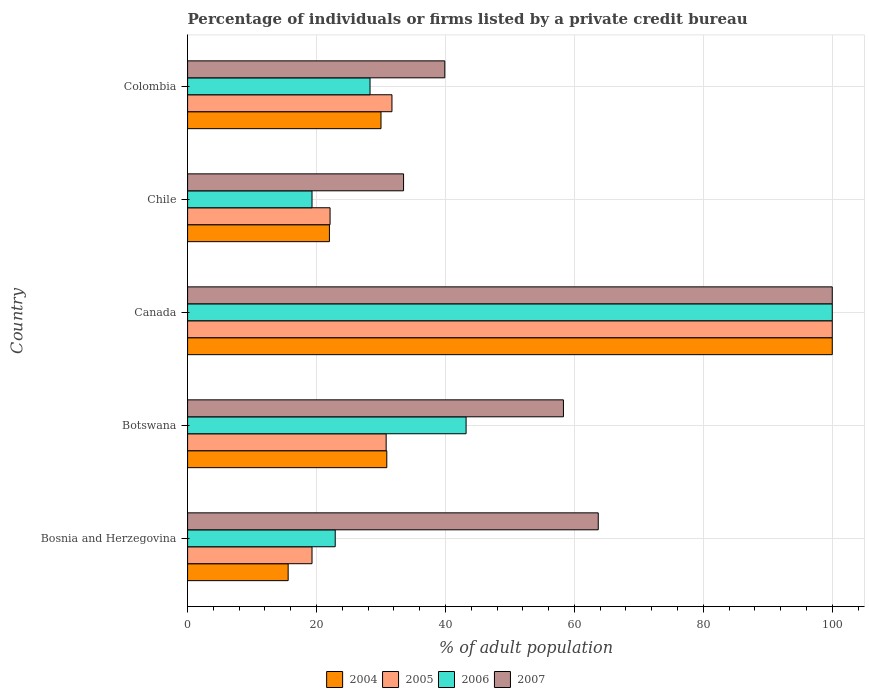Are the number of bars per tick equal to the number of legend labels?
Provide a succinct answer. Yes. Are the number of bars on each tick of the Y-axis equal?
Offer a terse response. Yes. How many bars are there on the 1st tick from the top?
Make the answer very short. 4. How many bars are there on the 1st tick from the bottom?
Provide a succinct answer. 4. What is the label of the 3rd group of bars from the top?
Offer a very short reply. Canada. What is the percentage of population listed by a private credit bureau in 2005 in Bosnia and Herzegovina?
Ensure brevity in your answer.  19.3. Across all countries, what is the maximum percentage of population listed by a private credit bureau in 2005?
Offer a terse response. 100. Across all countries, what is the minimum percentage of population listed by a private credit bureau in 2007?
Your answer should be very brief. 33.5. What is the total percentage of population listed by a private credit bureau in 2006 in the graph?
Your answer should be very brief. 213.7. What is the difference between the percentage of population listed by a private credit bureau in 2004 in Botswana and that in Colombia?
Offer a very short reply. 0.9. What is the difference between the percentage of population listed by a private credit bureau in 2007 in Bosnia and Herzegovina and the percentage of population listed by a private credit bureau in 2006 in Canada?
Provide a short and direct response. -36.3. What is the average percentage of population listed by a private credit bureau in 2007 per country?
Your answer should be compact. 59.08. What is the difference between the percentage of population listed by a private credit bureau in 2006 and percentage of population listed by a private credit bureau in 2005 in Bosnia and Herzegovina?
Ensure brevity in your answer.  3.6. What is the ratio of the percentage of population listed by a private credit bureau in 2004 in Botswana to that in Canada?
Make the answer very short. 0.31. Is the percentage of population listed by a private credit bureau in 2006 in Botswana less than that in Colombia?
Your answer should be very brief. No. Is the difference between the percentage of population listed by a private credit bureau in 2006 in Canada and Colombia greater than the difference between the percentage of population listed by a private credit bureau in 2005 in Canada and Colombia?
Offer a very short reply. Yes. What is the difference between the highest and the second highest percentage of population listed by a private credit bureau in 2005?
Your response must be concise. 68.3. What is the difference between the highest and the lowest percentage of population listed by a private credit bureau in 2007?
Ensure brevity in your answer.  66.5. Is it the case that in every country, the sum of the percentage of population listed by a private credit bureau in 2005 and percentage of population listed by a private credit bureau in 2006 is greater than the sum of percentage of population listed by a private credit bureau in 2004 and percentage of population listed by a private credit bureau in 2007?
Ensure brevity in your answer.  No. What does the 3rd bar from the top in Bosnia and Herzegovina represents?
Keep it short and to the point. 2005. What does the 1st bar from the bottom in Colombia represents?
Offer a terse response. 2004. Is it the case that in every country, the sum of the percentage of population listed by a private credit bureau in 2007 and percentage of population listed by a private credit bureau in 2006 is greater than the percentage of population listed by a private credit bureau in 2004?
Your answer should be compact. Yes. How many bars are there?
Your answer should be very brief. 20. Does the graph contain any zero values?
Keep it short and to the point. No. Does the graph contain grids?
Provide a short and direct response. Yes. What is the title of the graph?
Give a very brief answer. Percentage of individuals or firms listed by a private credit bureau. What is the label or title of the X-axis?
Offer a very short reply. % of adult population. What is the % of adult population of 2005 in Bosnia and Herzegovina?
Provide a short and direct response. 19.3. What is the % of adult population in 2006 in Bosnia and Herzegovina?
Offer a terse response. 22.9. What is the % of adult population of 2007 in Bosnia and Herzegovina?
Make the answer very short. 63.7. What is the % of adult population in 2004 in Botswana?
Provide a short and direct response. 30.9. What is the % of adult population in 2005 in Botswana?
Give a very brief answer. 30.8. What is the % of adult population in 2006 in Botswana?
Provide a short and direct response. 43.2. What is the % of adult population of 2007 in Botswana?
Offer a terse response. 58.3. What is the % of adult population in 2004 in Canada?
Your answer should be very brief. 100. What is the % of adult population of 2007 in Canada?
Ensure brevity in your answer.  100. What is the % of adult population in 2004 in Chile?
Your answer should be compact. 22. What is the % of adult population in 2005 in Chile?
Provide a succinct answer. 22.1. What is the % of adult population in 2006 in Chile?
Your answer should be very brief. 19.3. What is the % of adult population of 2007 in Chile?
Keep it short and to the point. 33.5. What is the % of adult population in 2004 in Colombia?
Provide a short and direct response. 30. What is the % of adult population in 2005 in Colombia?
Offer a terse response. 31.7. What is the % of adult population of 2006 in Colombia?
Offer a very short reply. 28.3. What is the % of adult population in 2007 in Colombia?
Provide a succinct answer. 39.9. Across all countries, what is the maximum % of adult population in 2004?
Make the answer very short. 100. Across all countries, what is the maximum % of adult population of 2005?
Give a very brief answer. 100. Across all countries, what is the maximum % of adult population in 2007?
Ensure brevity in your answer.  100. Across all countries, what is the minimum % of adult population in 2005?
Give a very brief answer. 19.3. Across all countries, what is the minimum % of adult population of 2006?
Offer a very short reply. 19.3. Across all countries, what is the minimum % of adult population in 2007?
Give a very brief answer. 33.5. What is the total % of adult population of 2004 in the graph?
Your answer should be compact. 198.5. What is the total % of adult population in 2005 in the graph?
Your answer should be very brief. 203.9. What is the total % of adult population in 2006 in the graph?
Give a very brief answer. 213.7. What is the total % of adult population of 2007 in the graph?
Provide a succinct answer. 295.4. What is the difference between the % of adult population in 2004 in Bosnia and Herzegovina and that in Botswana?
Provide a succinct answer. -15.3. What is the difference between the % of adult population in 2005 in Bosnia and Herzegovina and that in Botswana?
Provide a succinct answer. -11.5. What is the difference between the % of adult population in 2006 in Bosnia and Herzegovina and that in Botswana?
Give a very brief answer. -20.3. What is the difference between the % of adult population in 2007 in Bosnia and Herzegovina and that in Botswana?
Make the answer very short. 5.4. What is the difference between the % of adult population of 2004 in Bosnia and Herzegovina and that in Canada?
Give a very brief answer. -84.4. What is the difference between the % of adult population in 2005 in Bosnia and Herzegovina and that in Canada?
Ensure brevity in your answer.  -80.7. What is the difference between the % of adult population of 2006 in Bosnia and Herzegovina and that in Canada?
Keep it short and to the point. -77.1. What is the difference between the % of adult population of 2007 in Bosnia and Herzegovina and that in Canada?
Your response must be concise. -36.3. What is the difference between the % of adult population in 2004 in Bosnia and Herzegovina and that in Chile?
Offer a very short reply. -6.4. What is the difference between the % of adult population of 2005 in Bosnia and Herzegovina and that in Chile?
Provide a short and direct response. -2.8. What is the difference between the % of adult population in 2006 in Bosnia and Herzegovina and that in Chile?
Offer a terse response. 3.6. What is the difference between the % of adult population of 2007 in Bosnia and Herzegovina and that in Chile?
Offer a very short reply. 30.2. What is the difference between the % of adult population of 2004 in Bosnia and Herzegovina and that in Colombia?
Keep it short and to the point. -14.4. What is the difference between the % of adult population in 2006 in Bosnia and Herzegovina and that in Colombia?
Provide a succinct answer. -5.4. What is the difference between the % of adult population of 2007 in Bosnia and Herzegovina and that in Colombia?
Offer a very short reply. 23.8. What is the difference between the % of adult population of 2004 in Botswana and that in Canada?
Give a very brief answer. -69.1. What is the difference between the % of adult population of 2005 in Botswana and that in Canada?
Make the answer very short. -69.2. What is the difference between the % of adult population of 2006 in Botswana and that in Canada?
Your answer should be very brief. -56.8. What is the difference between the % of adult population in 2007 in Botswana and that in Canada?
Provide a short and direct response. -41.7. What is the difference between the % of adult population of 2004 in Botswana and that in Chile?
Keep it short and to the point. 8.9. What is the difference between the % of adult population of 2006 in Botswana and that in Chile?
Provide a succinct answer. 23.9. What is the difference between the % of adult population in 2007 in Botswana and that in Chile?
Your answer should be compact. 24.8. What is the difference between the % of adult population of 2004 in Botswana and that in Colombia?
Keep it short and to the point. 0.9. What is the difference between the % of adult population in 2005 in Botswana and that in Colombia?
Your answer should be compact. -0.9. What is the difference between the % of adult population in 2006 in Botswana and that in Colombia?
Provide a short and direct response. 14.9. What is the difference between the % of adult population of 2004 in Canada and that in Chile?
Keep it short and to the point. 78. What is the difference between the % of adult population in 2005 in Canada and that in Chile?
Keep it short and to the point. 77.9. What is the difference between the % of adult population in 2006 in Canada and that in Chile?
Keep it short and to the point. 80.7. What is the difference between the % of adult population in 2007 in Canada and that in Chile?
Your answer should be very brief. 66.5. What is the difference between the % of adult population in 2004 in Canada and that in Colombia?
Your answer should be compact. 70. What is the difference between the % of adult population of 2005 in Canada and that in Colombia?
Make the answer very short. 68.3. What is the difference between the % of adult population in 2006 in Canada and that in Colombia?
Ensure brevity in your answer.  71.7. What is the difference between the % of adult population in 2007 in Canada and that in Colombia?
Provide a short and direct response. 60.1. What is the difference between the % of adult population of 2006 in Chile and that in Colombia?
Offer a very short reply. -9. What is the difference between the % of adult population of 2004 in Bosnia and Herzegovina and the % of adult population of 2005 in Botswana?
Make the answer very short. -15.2. What is the difference between the % of adult population of 2004 in Bosnia and Herzegovina and the % of adult population of 2006 in Botswana?
Your answer should be compact. -27.6. What is the difference between the % of adult population of 2004 in Bosnia and Herzegovina and the % of adult population of 2007 in Botswana?
Offer a very short reply. -42.7. What is the difference between the % of adult population of 2005 in Bosnia and Herzegovina and the % of adult population of 2006 in Botswana?
Keep it short and to the point. -23.9. What is the difference between the % of adult population of 2005 in Bosnia and Herzegovina and the % of adult population of 2007 in Botswana?
Ensure brevity in your answer.  -39. What is the difference between the % of adult population in 2006 in Bosnia and Herzegovina and the % of adult population in 2007 in Botswana?
Your answer should be very brief. -35.4. What is the difference between the % of adult population of 2004 in Bosnia and Herzegovina and the % of adult population of 2005 in Canada?
Your answer should be very brief. -84.4. What is the difference between the % of adult population in 2004 in Bosnia and Herzegovina and the % of adult population in 2006 in Canada?
Offer a very short reply. -84.4. What is the difference between the % of adult population in 2004 in Bosnia and Herzegovina and the % of adult population in 2007 in Canada?
Make the answer very short. -84.4. What is the difference between the % of adult population in 2005 in Bosnia and Herzegovina and the % of adult population in 2006 in Canada?
Provide a succinct answer. -80.7. What is the difference between the % of adult population of 2005 in Bosnia and Herzegovina and the % of adult population of 2007 in Canada?
Ensure brevity in your answer.  -80.7. What is the difference between the % of adult population in 2006 in Bosnia and Herzegovina and the % of adult population in 2007 in Canada?
Offer a terse response. -77.1. What is the difference between the % of adult population in 2004 in Bosnia and Herzegovina and the % of adult population in 2005 in Chile?
Your response must be concise. -6.5. What is the difference between the % of adult population of 2004 in Bosnia and Herzegovina and the % of adult population of 2007 in Chile?
Your answer should be compact. -17.9. What is the difference between the % of adult population in 2005 in Bosnia and Herzegovina and the % of adult population in 2006 in Chile?
Offer a terse response. 0. What is the difference between the % of adult population of 2005 in Bosnia and Herzegovina and the % of adult population of 2007 in Chile?
Keep it short and to the point. -14.2. What is the difference between the % of adult population of 2004 in Bosnia and Herzegovina and the % of adult population of 2005 in Colombia?
Your response must be concise. -16.1. What is the difference between the % of adult population of 2004 in Bosnia and Herzegovina and the % of adult population of 2006 in Colombia?
Offer a terse response. -12.7. What is the difference between the % of adult population in 2004 in Bosnia and Herzegovina and the % of adult population in 2007 in Colombia?
Your answer should be compact. -24.3. What is the difference between the % of adult population in 2005 in Bosnia and Herzegovina and the % of adult population in 2006 in Colombia?
Your answer should be very brief. -9. What is the difference between the % of adult population of 2005 in Bosnia and Herzegovina and the % of adult population of 2007 in Colombia?
Your response must be concise. -20.6. What is the difference between the % of adult population of 2006 in Bosnia and Herzegovina and the % of adult population of 2007 in Colombia?
Your response must be concise. -17. What is the difference between the % of adult population of 2004 in Botswana and the % of adult population of 2005 in Canada?
Your response must be concise. -69.1. What is the difference between the % of adult population in 2004 in Botswana and the % of adult population in 2006 in Canada?
Ensure brevity in your answer.  -69.1. What is the difference between the % of adult population of 2004 in Botswana and the % of adult population of 2007 in Canada?
Your answer should be very brief. -69.1. What is the difference between the % of adult population of 2005 in Botswana and the % of adult population of 2006 in Canada?
Make the answer very short. -69.2. What is the difference between the % of adult population in 2005 in Botswana and the % of adult population in 2007 in Canada?
Offer a very short reply. -69.2. What is the difference between the % of adult population of 2006 in Botswana and the % of adult population of 2007 in Canada?
Give a very brief answer. -56.8. What is the difference between the % of adult population in 2004 in Botswana and the % of adult population in 2007 in Chile?
Your response must be concise. -2.6. What is the difference between the % of adult population in 2006 in Botswana and the % of adult population in 2007 in Chile?
Your answer should be compact. 9.7. What is the difference between the % of adult population in 2004 in Botswana and the % of adult population in 2005 in Colombia?
Ensure brevity in your answer.  -0.8. What is the difference between the % of adult population in 2005 in Botswana and the % of adult population in 2006 in Colombia?
Your answer should be very brief. 2.5. What is the difference between the % of adult population of 2005 in Botswana and the % of adult population of 2007 in Colombia?
Offer a very short reply. -9.1. What is the difference between the % of adult population in 2006 in Botswana and the % of adult population in 2007 in Colombia?
Make the answer very short. 3.3. What is the difference between the % of adult population of 2004 in Canada and the % of adult population of 2005 in Chile?
Offer a terse response. 77.9. What is the difference between the % of adult population of 2004 in Canada and the % of adult population of 2006 in Chile?
Provide a succinct answer. 80.7. What is the difference between the % of adult population of 2004 in Canada and the % of adult population of 2007 in Chile?
Offer a terse response. 66.5. What is the difference between the % of adult population in 2005 in Canada and the % of adult population in 2006 in Chile?
Offer a very short reply. 80.7. What is the difference between the % of adult population of 2005 in Canada and the % of adult population of 2007 in Chile?
Offer a terse response. 66.5. What is the difference between the % of adult population in 2006 in Canada and the % of adult population in 2007 in Chile?
Your response must be concise. 66.5. What is the difference between the % of adult population of 2004 in Canada and the % of adult population of 2005 in Colombia?
Your answer should be compact. 68.3. What is the difference between the % of adult population in 2004 in Canada and the % of adult population in 2006 in Colombia?
Provide a short and direct response. 71.7. What is the difference between the % of adult population in 2004 in Canada and the % of adult population in 2007 in Colombia?
Give a very brief answer. 60.1. What is the difference between the % of adult population of 2005 in Canada and the % of adult population of 2006 in Colombia?
Your answer should be compact. 71.7. What is the difference between the % of adult population of 2005 in Canada and the % of adult population of 2007 in Colombia?
Offer a very short reply. 60.1. What is the difference between the % of adult population of 2006 in Canada and the % of adult population of 2007 in Colombia?
Make the answer very short. 60.1. What is the difference between the % of adult population in 2004 in Chile and the % of adult population in 2007 in Colombia?
Give a very brief answer. -17.9. What is the difference between the % of adult population in 2005 in Chile and the % of adult population in 2007 in Colombia?
Your answer should be compact. -17.8. What is the difference between the % of adult population of 2006 in Chile and the % of adult population of 2007 in Colombia?
Your response must be concise. -20.6. What is the average % of adult population of 2004 per country?
Give a very brief answer. 39.7. What is the average % of adult population in 2005 per country?
Provide a succinct answer. 40.78. What is the average % of adult population in 2006 per country?
Keep it short and to the point. 42.74. What is the average % of adult population in 2007 per country?
Provide a succinct answer. 59.08. What is the difference between the % of adult population in 2004 and % of adult population in 2006 in Bosnia and Herzegovina?
Your response must be concise. -7.3. What is the difference between the % of adult population in 2004 and % of adult population in 2007 in Bosnia and Herzegovina?
Offer a very short reply. -48.1. What is the difference between the % of adult population in 2005 and % of adult population in 2006 in Bosnia and Herzegovina?
Make the answer very short. -3.6. What is the difference between the % of adult population in 2005 and % of adult population in 2007 in Bosnia and Herzegovina?
Your response must be concise. -44.4. What is the difference between the % of adult population of 2006 and % of adult population of 2007 in Bosnia and Herzegovina?
Offer a very short reply. -40.8. What is the difference between the % of adult population of 2004 and % of adult population of 2005 in Botswana?
Provide a short and direct response. 0.1. What is the difference between the % of adult population in 2004 and % of adult population in 2006 in Botswana?
Provide a succinct answer. -12.3. What is the difference between the % of adult population of 2004 and % of adult population of 2007 in Botswana?
Your answer should be very brief. -27.4. What is the difference between the % of adult population in 2005 and % of adult population in 2006 in Botswana?
Provide a succinct answer. -12.4. What is the difference between the % of adult population in 2005 and % of adult population in 2007 in Botswana?
Provide a short and direct response. -27.5. What is the difference between the % of adult population of 2006 and % of adult population of 2007 in Botswana?
Offer a very short reply. -15.1. What is the difference between the % of adult population in 2004 and % of adult population in 2005 in Canada?
Your answer should be very brief. 0. What is the difference between the % of adult population in 2004 and % of adult population in 2007 in Canada?
Your response must be concise. 0. What is the difference between the % of adult population of 2005 and % of adult population of 2006 in Canada?
Your answer should be very brief. 0. What is the difference between the % of adult population in 2005 and % of adult population in 2007 in Canada?
Your answer should be very brief. 0. What is the difference between the % of adult population in 2004 and % of adult population in 2005 in Chile?
Your answer should be very brief. -0.1. What is the difference between the % of adult population of 2004 and % of adult population of 2006 in Chile?
Keep it short and to the point. 2.7. What is the difference between the % of adult population in 2005 and % of adult population in 2007 in Chile?
Make the answer very short. -11.4. What is the difference between the % of adult population of 2006 and % of adult population of 2007 in Chile?
Offer a terse response. -14.2. What is the difference between the % of adult population of 2004 and % of adult population of 2006 in Colombia?
Give a very brief answer. 1.7. What is the difference between the % of adult population in 2004 and % of adult population in 2007 in Colombia?
Ensure brevity in your answer.  -9.9. What is the difference between the % of adult population of 2005 and % of adult population of 2006 in Colombia?
Provide a succinct answer. 3.4. What is the difference between the % of adult population in 2005 and % of adult population in 2007 in Colombia?
Keep it short and to the point. -8.2. What is the difference between the % of adult population of 2006 and % of adult population of 2007 in Colombia?
Offer a terse response. -11.6. What is the ratio of the % of adult population in 2004 in Bosnia and Herzegovina to that in Botswana?
Your answer should be compact. 0.5. What is the ratio of the % of adult population of 2005 in Bosnia and Herzegovina to that in Botswana?
Provide a succinct answer. 0.63. What is the ratio of the % of adult population in 2006 in Bosnia and Herzegovina to that in Botswana?
Keep it short and to the point. 0.53. What is the ratio of the % of adult population of 2007 in Bosnia and Herzegovina to that in Botswana?
Provide a succinct answer. 1.09. What is the ratio of the % of adult population of 2004 in Bosnia and Herzegovina to that in Canada?
Give a very brief answer. 0.16. What is the ratio of the % of adult population in 2005 in Bosnia and Herzegovina to that in Canada?
Your response must be concise. 0.19. What is the ratio of the % of adult population of 2006 in Bosnia and Herzegovina to that in Canada?
Offer a terse response. 0.23. What is the ratio of the % of adult population in 2007 in Bosnia and Herzegovina to that in Canada?
Your response must be concise. 0.64. What is the ratio of the % of adult population of 2004 in Bosnia and Herzegovina to that in Chile?
Make the answer very short. 0.71. What is the ratio of the % of adult population in 2005 in Bosnia and Herzegovina to that in Chile?
Ensure brevity in your answer.  0.87. What is the ratio of the % of adult population in 2006 in Bosnia and Herzegovina to that in Chile?
Give a very brief answer. 1.19. What is the ratio of the % of adult population of 2007 in Bosnia and Herzegovina to that in Chile?
Your answer should be compact. 1.9. What is the ratio of the % of adult population in 2004 in Bosnia and Herzegovina to that in Colombia?
Ensure brevity in your answer.  0.52. What is the ratio of the % of adult population in 2005 in Bosnia and Herzegovina to that in Colombia?
Ensure brevity in your answer.  0.61. What is the ratio of the % of adult population in 2006 in Bosnia and Herzegovina to that in Colombia?
Provide a succinct answer. 0.81. What is the ratio of the % of adult population in 2007 in Bosnia and Herzegovina to that in Colombia?
Your answer should be very brief. 1.6. What is the ratio of the % of adult population in 2004 in Botswana to that in Canada?
Give a very brief answer. 0.31. What is the ratio of the % of adult population in 2005 in Botswana to that in Canada?
Provide a succinct answer. 0.31. What is the ratio of the % of adult population in 2006 in Botswana to that in Canada?
Provide a short and direct response. 0.43. What is the ratio of the % of adult population of 2007 in Botswana to that in Canada?
Provide a short and direct response. 0.58. What is the ratio of the % of adult population of 2004 in Botswana to that in Chile?
Offer a terse response. 1.4. What is the ratio of the % of adult population in 2005 in Botswana to that in Chile?
Your answer should be compact. 1.39. What is the ratio of the % of adult population of 2006 in Botswana to that in Chile?
Your answer should be very brief. 2.24. What is the ratio of the % of adult population in 2007 in Botswana to that in Chile?
Keep it short and to the point. 1.74. What is the ratio of the % of adult population in 2004 in Botswana to that in Colombia?
Offer a very short reply. 1.03. What is the ratio of the % of adult population in 2005 in Botswana to that in Colombia?
Your answer should be very brief. 0.97. What is the ratio of the % of adult population of 2006 in Botswana to that in Colombia?
Provide a succinct answer. 1.53. What is the ratio of the % of adult population of 2007 in Botswana to that in Colombia?
Ensure brevity in your answer.  1.46. What is the ratio of the % of adult population of 2004 in Canada to that in Chile?
Your response must be concise. 4.55. What is the ratio of the % of adult population in 2005 in Canada to that in Chile?
Make the answer very short. 4.52. What is the ratio of the % of adult population of 2006 in Canada to that in Chile?
Keep it short and to the point. 5.18. What is the ratio of the % of adult population of 2007 in Canada to that in Chile?
Make the answer very short. 2.99. What is the ratio of the % of adult population in 2005 in Canada to that in Colombia?
Offer a very short reply. 3.15. What is the ratio of the % of adult population in 2006 in Canada to that in Colombia?
Provide a succinct answer. 3.53. What is the ratio of the % of adult population of 2007 in Canada to that in Colombia?
Provide a short and direct response. 2.51. What is the ratio of the % of adult population of 2004 in Chile to that in Colombia?
Provide a short and direct response. 0.73. What is the ratio of the % of adult population in 2005 in Chile to that in Colombia?
Provide a succinct answer. 0.7. What is the ratio of the % of adult population of 2006 in Chile to that in Colombia?
Keep it short and to the point. 0.68. What is the ratio of the % of adult population in 2007 in Chile to that in Colombia?
Keep it short and to the point. 0.84. What is the difference between the highest and the second highest % of adult population of 2004?
Ensure brevity in your answer.  69.1. What is the difference between the highest and the second highest % of adult population of 2005?
Provide a succinct answer. 68.3. What is the difference between the highest and the second highest % of adult population of 2006?
Ensure brevity in your answer.  56.8. What is the difference between the highest and the second highest % of adult population in 2007?
Ensure brevity in your answer.  36.3. What is the difference between the highest and the lowest % of adult population of 2004?
Provide a short and direct response. 84.4. What is the difference between the highest and the lowest % of adult population in 2005?
Offer a terse response. 80.7. What is the difference between the highest and the lowest % of adult population of 2006?
Offer a terse response. 80.7. What is the difference between the highest and the lowest % of adult population of 2007?
Provide a succinct answer. 66.5. 